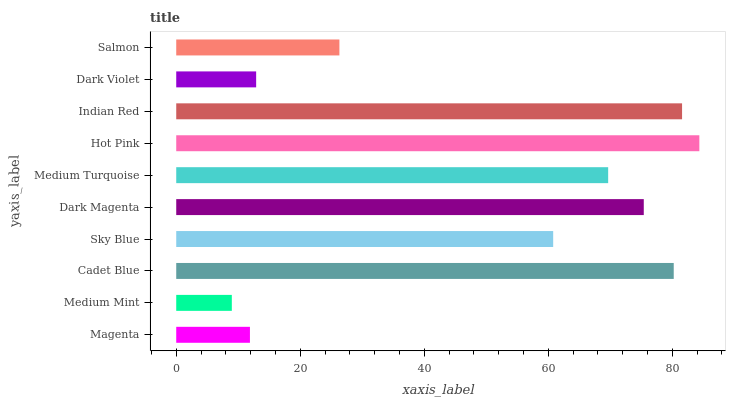Is Medium Mint the minimum?
Answer yes or no. Yes. Is Hot Pink the maximum?
Answer yes or no. Yes. Is Cadet Blue the minimum?
Answer yes or no. No. Is Cadet Blue the maximum?
Answer yes or no. No. Is Cadet Blue greater than Medium Mint?
Answer yes or no. Yes. Is Medium Mint less than Cadet Blue?
Answer yes or no. Yes. Is Medium Mint greater than Cadet Blue?
Answer yes or no. No. Is Cadet Blue less than Medium Mint?
Answer yes or no. No. Is Medium Turquoise the high median?
Answer yes or no. Yes. Is Sky Blue the low median?
Answer yes or no. Yes. Is Medium Mint the high median?
Answer yes or no. No. Is Indian Red the low median?
Answer yes or no. No. 